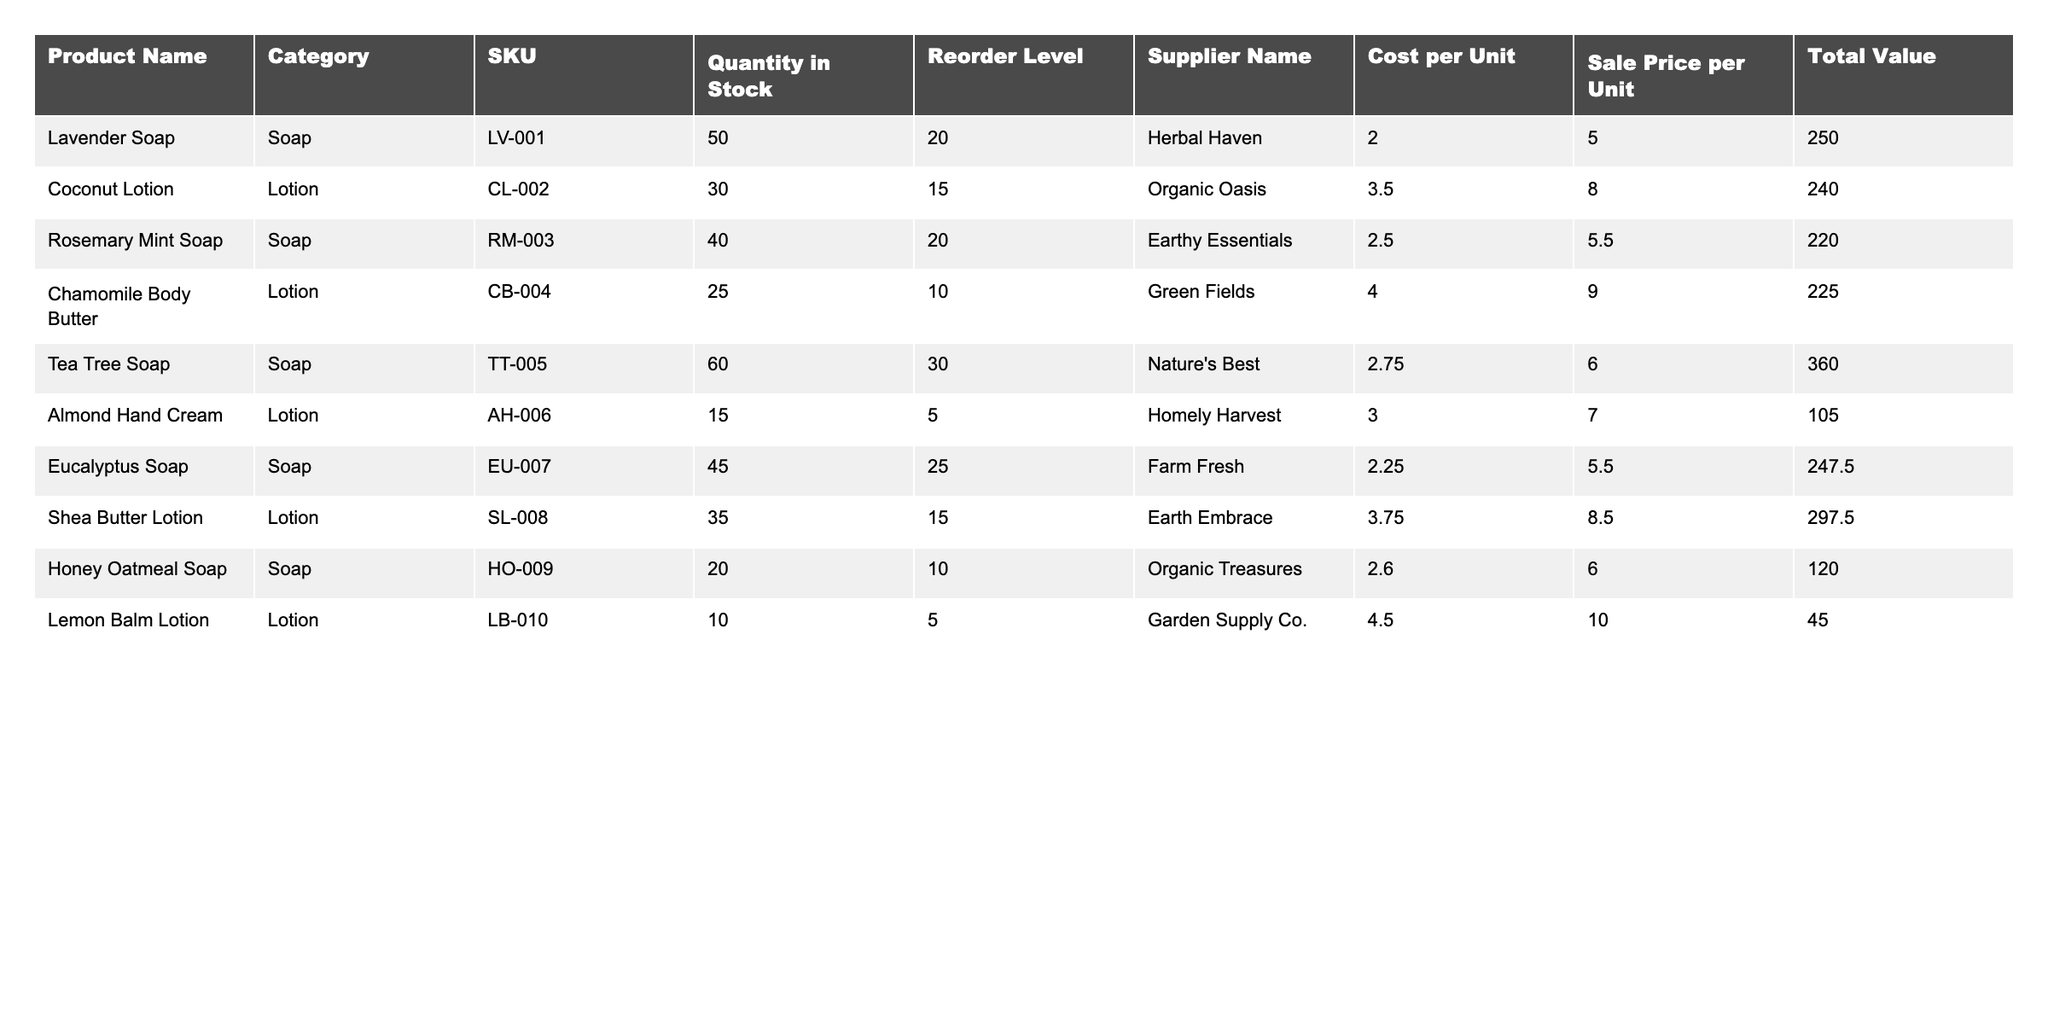What is the SKU for the Coconut Lotion? The SKU is listed directly in the table under the SKU column next to the Coconut Lotion entry. For Coconut Lotion, the SKU is CL-002.
Answer: CL-002 How many units of Lavender Soap are currently in stock? The quantity in stock for Lavender Soap is found in the corresponding row under the Quantity in Stock column. It shows 50 units.
Answer: 50 What is the total value of the Honey Oatmeal Soap? The total value is provided in the Total Value column for Honey Oatmeal Soap. Upon inspecting that cell, the total value is $120.00.
Answer: 120.00 Is the reorder level for Almond Hand Cream greater than its quantity in stock? The reorder level for Almond Hand Cream is 5, while the quantity in stock is 15. Since 15 is greater than 5, the statement is true.
Answer: Yes What is the combined total value of all soaps in inventory? First, we identify all soaps: Lavender Soap ($250), Rosemary Mint Soap ($220), Tea Tree Soap ($360), Eucalyptus Soap ($247.50), and Honey Oatmeal Soap ($120). We then sum these values: 250 + 220 + 360 + 247.50 + 120 = 1197.50.
Answer: 1197.50 Which Lotion has the highest cost per unit? We review the Cost per Unit column for lotions, which includes: Coconut Lotion ($3.50), Chamomile Body Butter ($4.00), Shea Butter Lotion ($3.75), and Lemon Balm Lotion ($4.50). The highest cost is from Lemon Balm Lotion at $4.50.
Answer: Lemon Balm Lotion What is the average quantity in stock for all products? We find the total quantity in stock by summing all quantities: 50 (Lavender) + 30 (Coconut) + 40 (Rosemary Mint) + 25 (Chamomile) + 60 (Tea Tree) + 15 (Almond) + 45 (Eucalyptus) + 35 (Shea Butter) + 20 (Honey Oatmeal) + 10 (Lemon Balm) =  50+30+40+25+60+15+45+35+20+10 = 320. There are 10 products, so the average is 320/10 = 32.
Answer: 32 How many products have a reorder level of 15 or lower? Check the Reorder Level column for each product: Coconut Lotion (15), Almond Hand Cream (5), Chamomile Body Butter (10), and Lemon Balm Lotion (5) meet the criteria. Therefore, there are 4 products below that reorder level.
Answer: 4 What is the total revenue if all Eucalyptus Soap is sold? The total revenue is calculated by multiplying the sale price per unit of Eucalyptus Soap ($5.50) by the quantity in stock (45). Thus, 45 * 5.50 = $247.50.
Answer: 247.50 If we restock Lavender Soap to 100 units, how much would it cost? The current quantity is 50, so we need to order 50 more units at a cost per unit of $2.00. The calculation is 50 * 2.00 = $100.
Answer: 100 